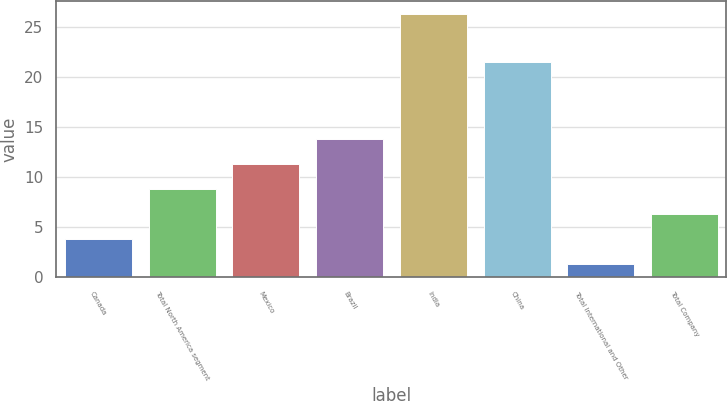Convert chart. <chart><loc_0><loc_0><loc_500><loc_500><bar_chart><fcel>Canada<fcel>Total North America segment<fcel>Mexico<fcel>Brazil<fcel>India<fcel>China<fcel>Total International and Other<fcel>Total Company<nl><fcel>3.8<fcel>8.8<fcel>11.3<fcel>13.8<fcel>26.3<fcel>21.5<fcel>1.3<fcel>6.3<nl></chart> 